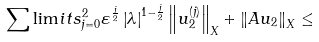<formula> <loc_0><loc_0><loc_500><loc_500>\sum \lim i t s _ { j = 0 } ^ { 2 } \varepsilon ^ { \frac { j } { 2 } } \left | \lambda \right | ^ { 1 - \frac { j } { 2 } } \left \| u _ { 2 } ^ { \left ( j \right ) } \right \| _ { X } + \left \| A u _ { 2 } \right \| _ { X } \leq</formula> 